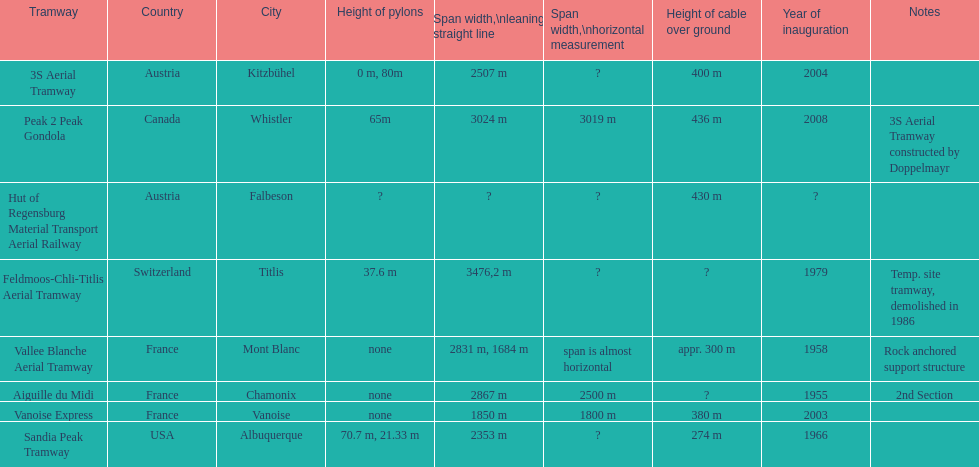Which tramway was built directly before the 3s aeriral tramway? Vanoise Express. 